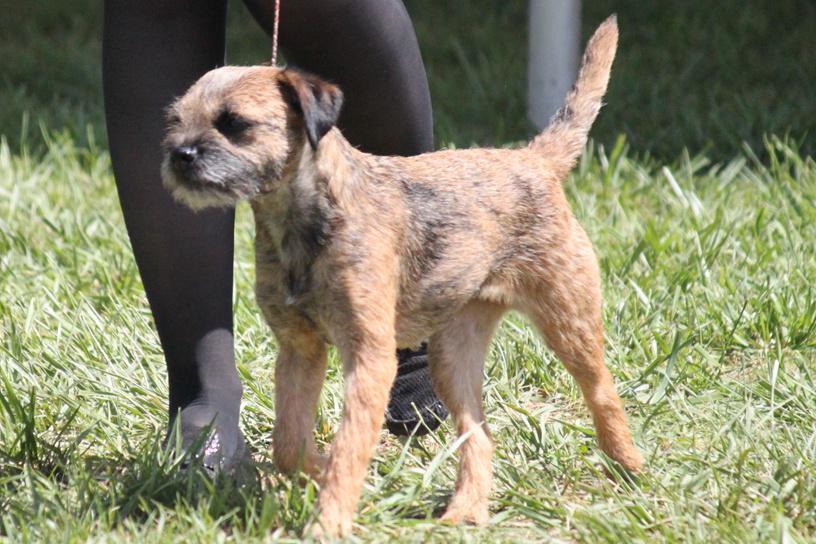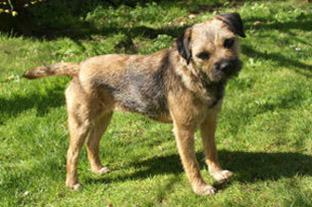The first image is the image on the left, the second image is the image on the right. Considering the images on both sides, is "Both images show dogs standing in profile with bodies and heads turned the same direction." valid? Answer yes or no. No. The first image is the image on the left, the second image is the image on the right. For the images shown, is this caption "The dog on the left is standing in the grass by a person." true? Answer yes or no. Yes. 